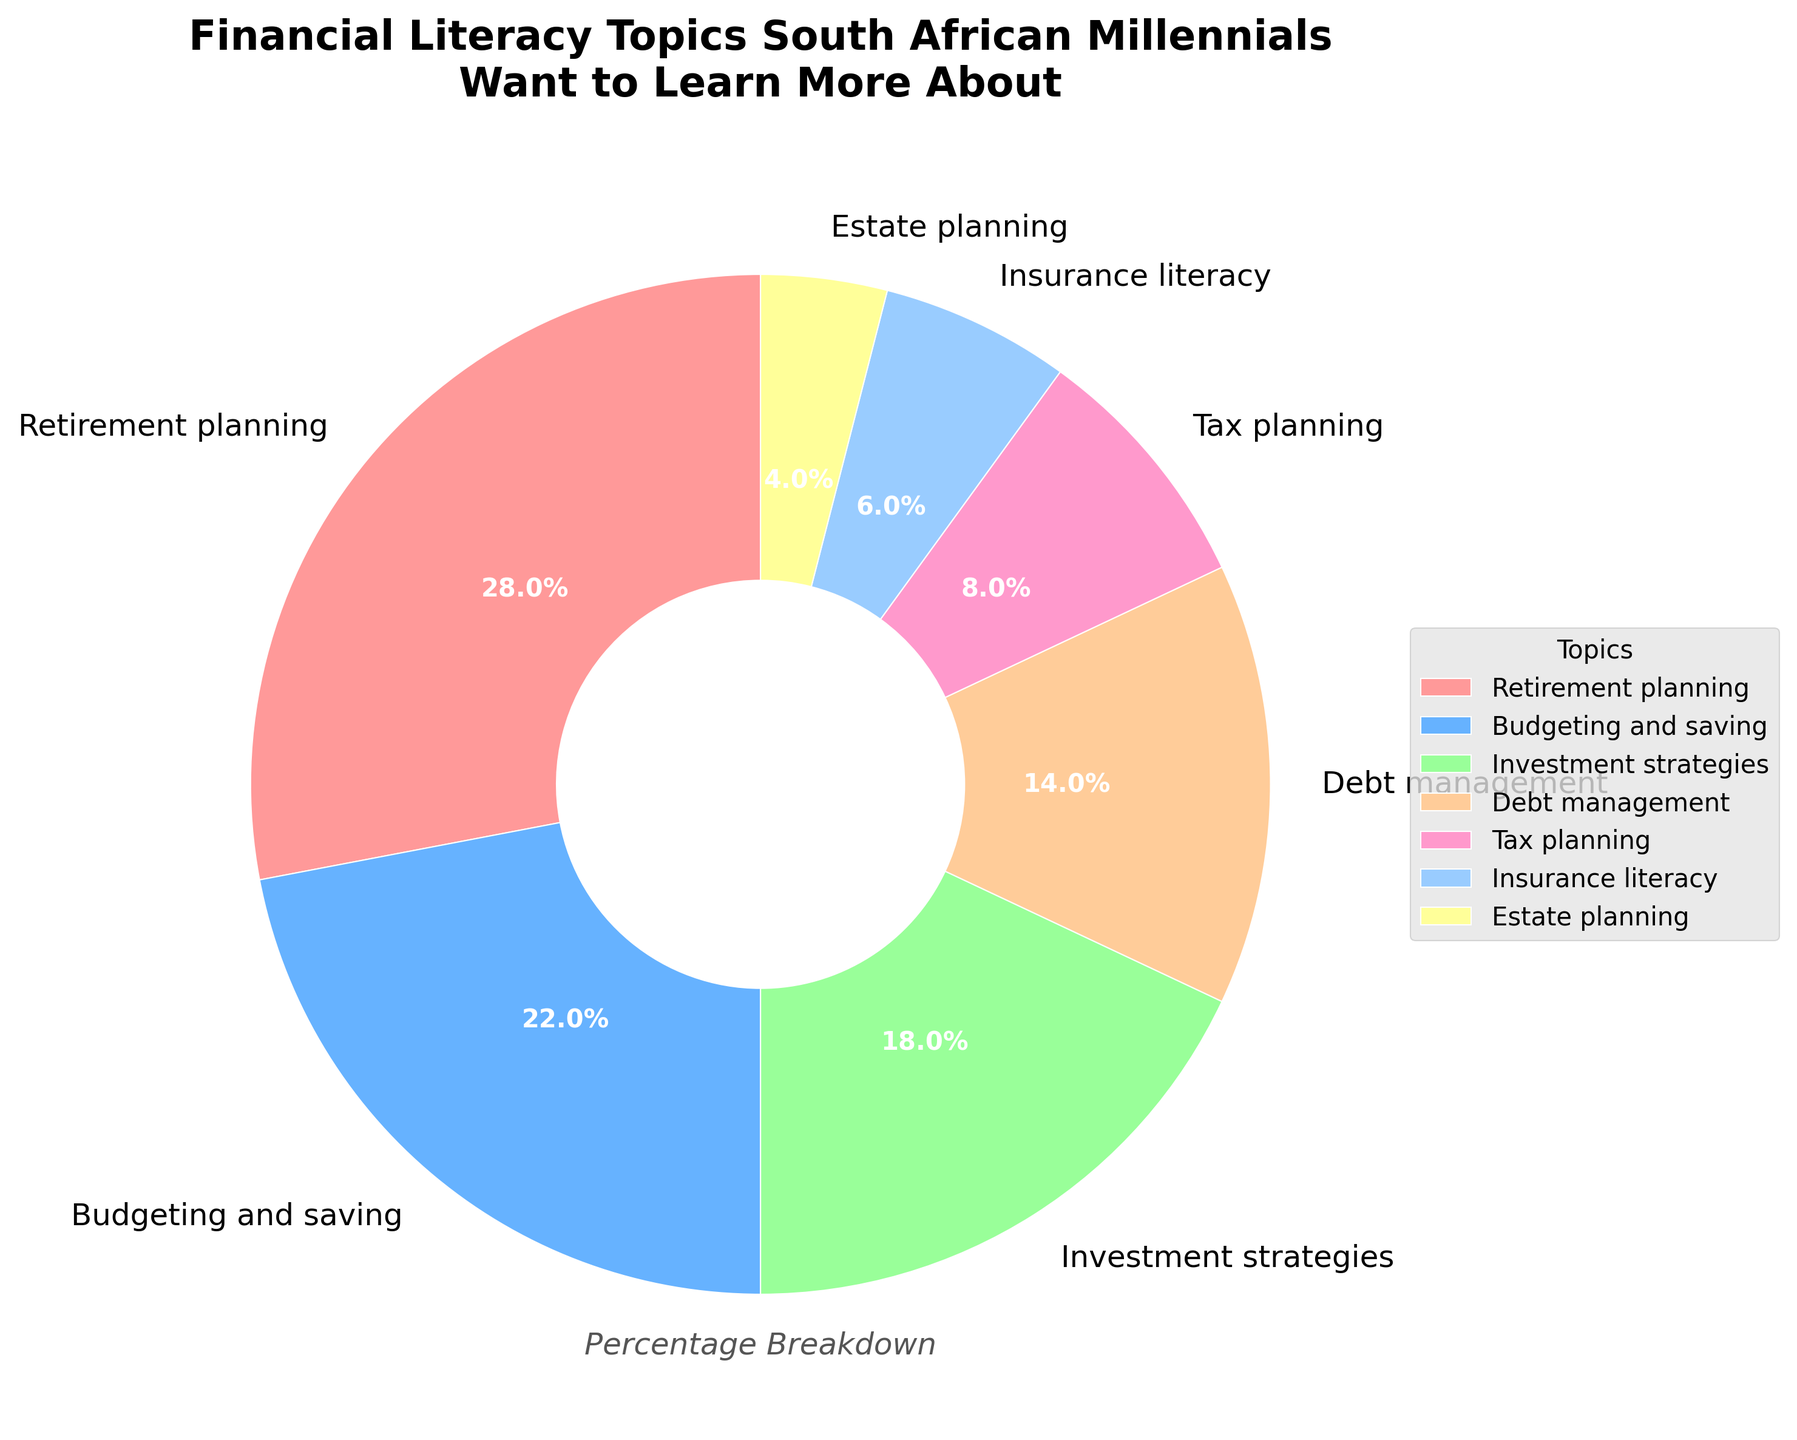What percentage of South African millennials want to learn about budgeting and saving? Find the segment labeled "Budgeting and saving" on the pie chart and read the percentage value associated with it, which is 22%.
Answer: 22% How many more percent of South African millennials are interested in retirement planning compared to estate planning? Find the percentages for "Retirement planning" (28%) and "Estate planning" (4%) in the pie chart. Subtract the percentage of estate planning from the percentage of retirement planning (28% - 4% = 24%).
Answer: 24% What is the combined percentage of millennials interested in debt management and tax planning? Identify the percentages for "Debt management" (14%) and "Tax planning" (8%) on the pie chart. Add these percentages together (14% + 8% = 22%).
Answer: 22% Compare the interest in investment strategies and insurance literacy among South African millennials. Which one has a higher percentage and by how much? Note the percentages for "Investment strategies" (18%) and "Insurance literacy" (6%) on the pie chart. Subtract the lower percentage from the higher percentage to find the difference (18% - 6% = 12%).
Answer: Investment strategies by 12% What color represents the topic with the smallest percentage of interest among South African millennials? Identify the topic with the smallest percentage, which is "Estate planning" at 4%. Find the corresponding color on the pie chart (yellow).
Answer: Yellow What topics cover at least 18% of the interest among South African millennials? Find all topics in the pie chart with percentages of 18% or more. These are "Retirement planning" (28%) and "Budgeting and saving" (22%).
Answer: Retirement planning, Budgeting and saving Which financial literacy topic has nearly a third of South African millennials interested in learning more about it? Look at the topics and their percentages on the pie chart. "Retirement planning" has the highest percentage, which is closest to one-third (28%).
Answer: Retirement planning What is the percentage difference between the most and least interesting financial literacy topics? Identify the most interesting topic ("Retirement planning" at 28%) and the least interesting topic ("Estate planning" at 4%) from the pie chart. Subtract the smallest percentage from the largest percentage (28% - 4% = 24%).
Answer: 24% Which topics combined represent more than half of the total interest among South African millennials? Sum the percentages of the high-interest topics on the pie chart until the total exceeds 50%. "Retirement planning" (28%) and "Budgeting and saving" (22%) together make 50%, but to exceed half, we need to add another topic like "Investment strategies" (18%), reaching a total of 68%.
Answer: Retirement planning, Budgeting and saving, Investment strategies 